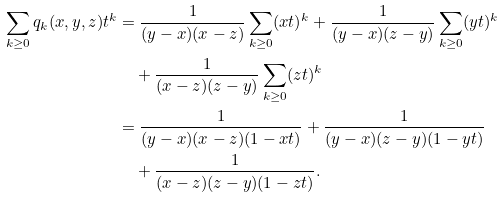<formula> <loc_0><loc_0><loc_500><loc_500>\sum _ { k \geq 0 } q _ { k } ( x , y , z ) t ^ { k } & = \frac { 1 } { ( y - x ) ( x - z ) } \sum _ { k \geq 0 } ( x t ) ^ { k } + \frac { 1 } { ( y - x ) ( z - y ) } \sum _ { k \geq 0 } ( y t ) ^ { k } \\ & \quad + \frac { 1 } { ( x - z ) ( z - y ) } \sum _ { k \geq 0 } ( z t ) ^ { k } \\ & = \frac { 1 } { ( y - x ) ( x - z ) ( 1 - x t ) } + \frac { 1 } { ( y - x ) ( z - y ) ( 1 - y t ) } \\ & \quad + \frac { 1 } { ( x - z ) ( z - y ) ( 1 - z t ) } .</formula> 